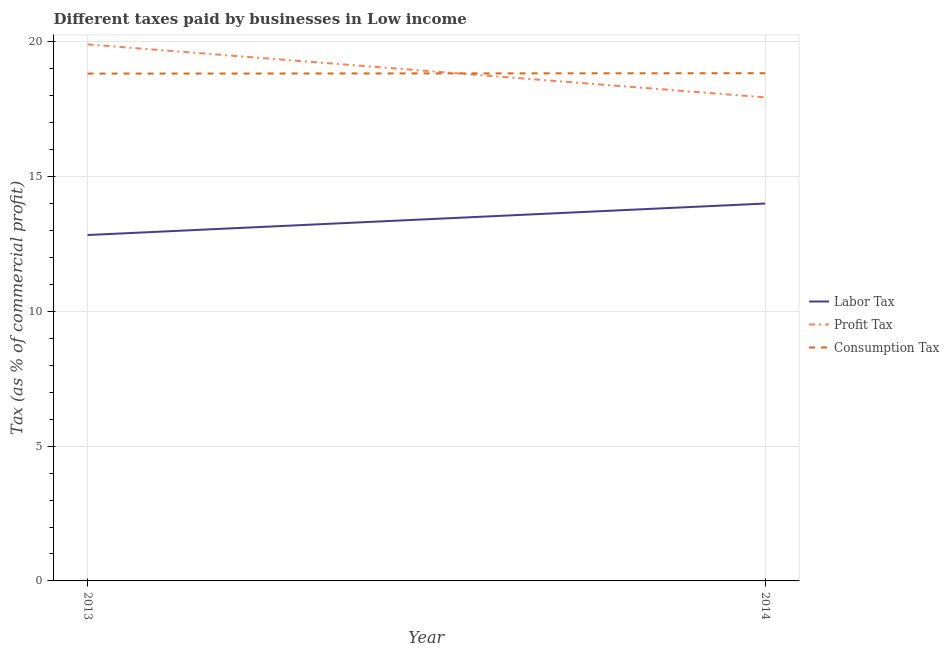Is the number of lines equal to the number of legend labels?
Your answer should be compact. Yes. What is the percentage of labor tax in 2013?
Provide a short and direct response. 12.83. Across all years, what is the maximum percentage of profit tax?
Ensure brevity in your answer.  19.9. Across all years, what is the minimum percentage of labor tax?
Your answer should be very brief. 12.83. In which year was the percentage of consumption tax maximum?
Your response must be concise. 2014. In which year was the percentage of consumption tax minimum?
Make the answer very short. 2013. What is the total percentage of labor tax in the graph?
Give a very brief answer. 26.83. What is the difference between the percentage of consumption tax in 2013 and that in 2014?
Your response must be concise. -0.01. What is the difference between the percentage of consumption tax in 2013 and the percentage of profit tax in 2014?
Keep it short and to the point. 0.88. What is the average percentage of consumption tax per year?
Give a very brief answer. 18.83. In the year 2014, what is the difference between the percentage of profit tax and percentage of consumption tax?
Offer a very short reply. -0.9. In how many years, is the percentage of consumption tax greater than 14 %?
Ensure brevity in your answer.  2. What is the ratio of the percentage of labor tax in 2013 to that in 2014?
Keep it short and to the point. 0.92. Is the percentage of profit tax in 2013 less than that in 2014?
Your response must be concise. No. Is it the case that in every year, the sum of the percentage of labor tax and percentage of profit tax is greater than the percentage of consumption tax?
Keep it short and to the point. Yes. Does the percentage of labor tax monotonically increase over the years?
Offer a very short reply. Yes. Is the percentage of consumption tax strictly less than the percentage of profit tax over the years?
Your answer should be very brief. No. How many years are there in the graph?
Provide a short and direct response. 2. Are the values on the major ticks of Y-axis written in scientific E-notation?
Provide a short and direct response. No. Does the graph contain grids?
Make the answer very short. Yes. How many legend labels are there?
Offer a terse response. 3. What is the title of the graph?
Provide a short and direct response. Different taxes paid by businesses in Low income. Does "Wage workers" appear as one of the legend labels in the graph?
Offer a very short reply. No. What is the label or title of the Y-axis?
Offer a very short reply. Tax (as % of commercial profit). What is the Tax (as % of commercial profit) of Labor Tax in 2013?
Give a very brief answer. 12.83. What is the Tax (as % of commercial profit) in Profit Tax in 2013?
Your response must be concise. 19.9. What is the Tax (as % of commercial profit) of Consumption Tax in 2013?
Your response must be concise. 18.82. What is the Tax (as % of commercial profit) of Labor Tax in 2014?
Offer a terse response. 14. What is the Tax (as % of commercial profit) of Profit Tax in 2014?
Your answer should be compact. 17.94. What is the Tax (as % of commercial profit) of Consumption Tax in 2014?
Ensure brevity in your answer.  18.83. Across all years, what is the maximum Tax (as % of commercial profit) of Labor Tax?
Offer a terse response. 14. Across all years, what is the maximum Tax (as % of commercial profit) in Profit Tax?
Your response must be concise. 19.9. Across all years, what is the maximum Tax (as % of commercial profit) in Consumption Tax?
Offer a terse response. 18.83. Across all years, what is the minimum Tax (as % of commercial profit) of Labor Tax?
Ensure brevity in your answer.  12.83. Across all years, what is the minimum Tax (as % of commercial profit) in Profit Tax?
Offer a very short reply. 17.94. Across all years, what is the minimum Tax (as % of commercial profit) in Consumption Tax?
Ensure brevity in your answer.  18.82. What is the total Tax (as % of commercial profit) in Labor Tax in the graph?
Give a very brief answer. 26.83. What is the total Tax (as % of commercial profit) in Profit Tax in the graph?
Ensure brevity in your answer.  37.84. What is the total Tax (as % of commercial profit) of Consumption Tax in the graph?
Your response must be concise. 37.66. What is the difference between the Tax (as % of commercial profit) of Labor Tax in 2013 and that in 2014?
Provide a succinct answer. -1.17. What is the difference between the Tax (as % of commercial profit) in Profit Tax in 2013 and that in 2014?
Keep it short and to the point. 1.97. What is the difference between the Tax (as % of commercial profit) of Consumption Tax in 2013 and that in 2014?
Give a very brief answer. -0.01. What is the difference between the Tax (as % of commercial profit) of Labor Tax in 2013 and the Tax (as % of commercial profit) of Profit Tax in 2014?
Your answer should be very brief. -5.11. What is the difference between the Tax (as % of commercial profit) of Labor Tax in 2013 and the Tax (as % of commercial profit) of Consumption Tax in 2014?
Make the answer very short. -6. What is the difference between the Tax (as % of commercial profit) of Profit Tax in 2013 and the Tax (as % of commercial profit) of Consumption Tax in 2014?
Make the answer very short. 1.07. What is the average Tax (as % of commercial profit) in Labor Tax per year?
Make the answer very short. 13.42. What is the average Tax (as % of commercial profit) of Profit Tax per year?
Offer a very short reply. 18.92. What is the average Tax (as % of commercial profit) in Consumption Tax per year?
Provide a succinct answer. 18.83. In the year 2013, what is the difference between the Tax (as % of commercial profit) in Labor Tax and Tax (as % of commercial profit) in Profit Tax?
Provide a short and direct response. -7.07. In the year 2013, what is the difference between the Tax (as % of commercial profit) of Labor Tax and Tax (as % of commercial profit) of Consumption Tax?
Make the answer very short. -5.99. In the year 2013, what is the difference between the Tax (as % of commercial profit) of Profit Tax and Tax (as % of commercial profit) of Consumption Tax?
Make the answer very short. 1.08. In the year 2014, what is the difference between the Tax (as % of commercial profit) in Labor Tax and Tax (as % of commercial profit) in Profit Tax?
Keep it short and to the point. -3.94. In the year 2014, what is the difference between the Tax (as % of commercial profit) in Labor Tax and Tax (as % of commercial profit) in Consumption Tax?
Offer a very short reply. -4.83. In the year 2014, what is the difference between the Tax (as % of commercial profit) of Profit Tax and Tax (as % of commercial profit) of Consumption Tax?
Keep it short and to the point. -0.9. What is the ratio of the Tax (as % of commercial profit) in Labor Tax in 2013 to that in 2014?
Keep it short and to the point. 0.92. What is the ratio of the Tax (as % of commercial profit) in Profit Tax in 2013 to that in 2014?
Give a very brief answer. 1.11. What is the difference between the highest and the second highest Tax (as % of commercial profit) of Labor Tax?
Offer a terse response. 1.17. What is the difference between the highest and the second highest Tax (as % of commercial profit) of Profit Tax?
Keep it short and to the point. 1.97. What is the difference between the highest and the second highest Tax (as % of commercial profit) in Consumption Tax?
Offer a terse response. 0.01. What is the difference between the highest and the lowest Tax (as % of commercial profit) in Labor Tax?
Offer a very short reply. 1.17. What is the difference between the highest and the lowest Tax (as % of commercial profit) in Profit Tax?
Offer a terse response. 1.97. What is the difference between the highest and the lowest Tax (as % of commercial profit) of Consumption Tax?
Make the answer very short. 0.01. 